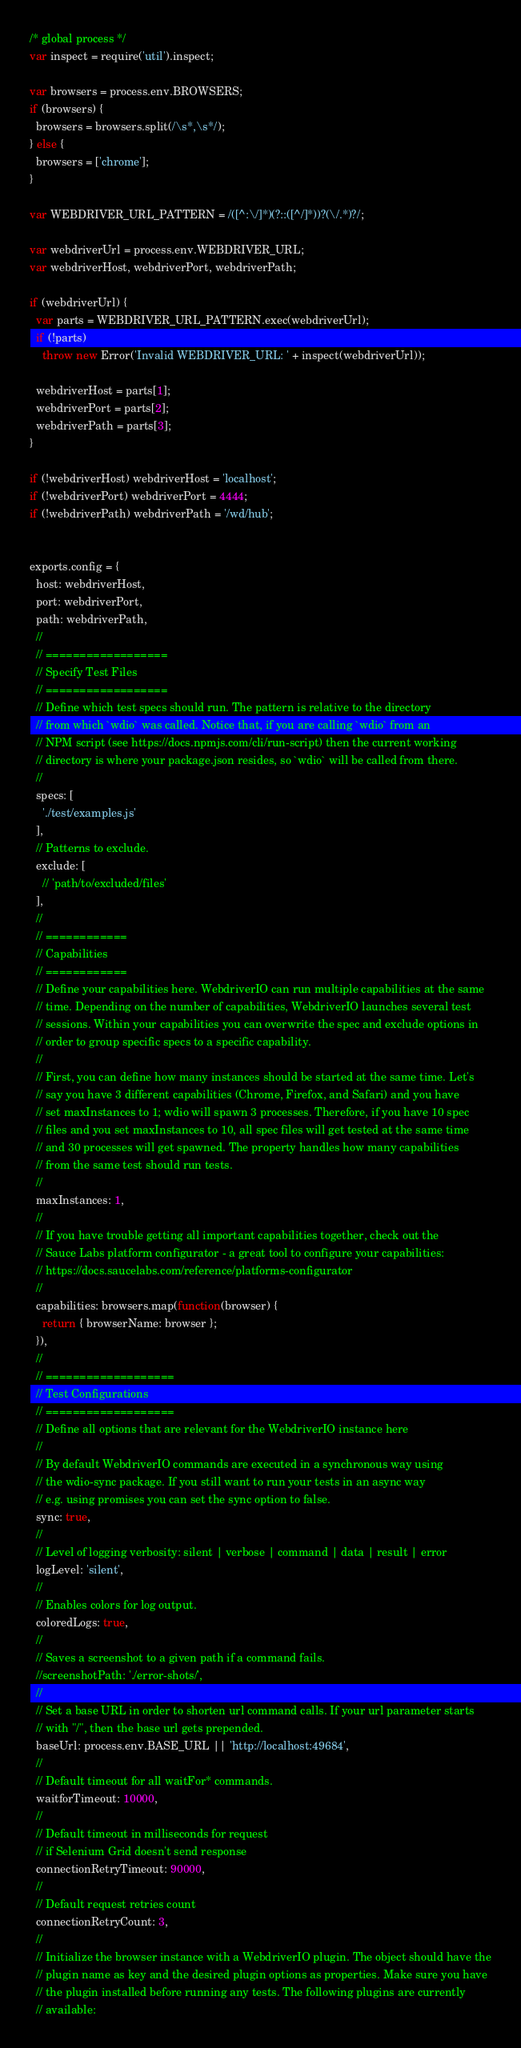<code> <loc_0><loc_0><loc_500><loc_500><_JavaScript_>/* global process */
var inspect = require('util').inspect;

var browsers = process.env.BROWSERS;
if (browsers) {
  browsers = browsers.split(/\s*,\s*/);
} else {
  browsers = ['chrome'];
}

var WEBDRIVER_URL_PATTERN = /([^:\/]*)(?::([^/]*))?(\/.*)?/;

var webdriverUrl = process.env.WEBDRIVER_URL;
var webdriverHost, webdriverPort, webdriverPath;

if (webdriverUrl) {
  var parts = WEBDRIVER_URL_PATTERN.exec(webdriverUrl);
  if (!parts)
    throw new Error('Invalid WEBDRIVER_URL: ' + inspect(webdriverUrl));

  webdriverHost = parts[1];
  webdriverPort = parts[2];
  webdriverPath = parts[3];
}

if (!webdriverHost) webdriverHost = 'localhost';
if (!webdriverPort) webdriverPort = 4444;
if (!webdriverPath) webdriverPath = '/wd/hub';


exports.config = {
  host: webdriverHost,
  port: webdriverPort,
  path: webdriverPath,
  //
  // ==================
  // Specify Test Files
  // ==================
  // Define which test specs should run. The pattern is relative to the directory
  // from which `wdio` was called. Notice that, if you are calling `wdio` from an
  // NPM script (see https://docs.npmjs.com/cli/run-script) then the current working
  // directory is where your package.json resides, so `wdio` will be called from there.
  //
  specs: [
    './test/examples.js'
  ],
  // Patterns to exclude.
  exclude: [
    // 'path/to/excluded/files'
  ],
  //
  // ============
  // Capabilities
  // ============
  // Define your capabilities here. WebdriverIO can run multiple capabilities at the same
  // time. Depending on the number of capabilities, WebdriverIO launches several test
  // sessions. Within your capabilities you can overwrite the spec and exclude options in
  // order to group specific specs to a specific capability.
  //
  // First, you can define how many instances should be started at the same time. Let's
  // say you have 3 different capabilities (Chrome, Firefox, and Safari) and you have
  // set maxInstances to 1; wdio will spawn 3 processes. Therefore, if you have 10 spec
  // files and you set maxInstances to 10, all spec files will get tested at the same time
  // and 30 processes will get spawned. The property handles how many capabilities
  // from the same test should run tests.
  //
  maxInstances: 1,
  //
  // If you have trouble getting all important capabilities together, check out the
  // Sauce Labs platform configurator - a great tool to configure your capabilities:
  // https://docs.saucelabs.com/reference/platforms-configurator
  //
  capabilities: browsers.map(function(browser) {
    return { browserName: browser };
  }),
  //
  // ===================
  // Test Configurations
  // ===================
  // Define all options that are relevant for the WebdriverIO instance here
  //
  // By default WebdriverIO commands are executed in a synchronous way using
  // the wdio-sync package. If you still want to run your tests in an async way
  // e.g. using promises you can set the sync option to false.
  sync: true,
  //
  // Level of logging verbosity: silent | verbose | command | data | result | error
  logLevel: 'silent',
  //
  // Enables colors for log output.
  coloredLogs: true,
  //
  // Saves a screenshot to a given path if a command fails.
  //screenshotPath: './error-shots/',
  //
  // Set a base URL in order to shorten url command calls. If your url parameter starts
  // with "/", then the base url gets prepended.
  baseUrl: process.env.BASE_URL || 'http://localhost:49684',
  //
  // Default timeout for all waitFor* commands.
  waitforTimeout: 10000,
  //
  // Default timeout in milliseconds for request
  // if Selenium Grid doesn't send response
  connectionRetryTimeout: 90000,
  //
  // Default request retries count
  connectionRetryCount: 3,
  //
  // Initialize the browser instance with a WebdriverIO plugin. The object should have the
  // plugin name as key and the desired plugin options as properties. Make sure you have
  // the plugin installed before running any tests. The following plugins are currently
  // available:</code> 